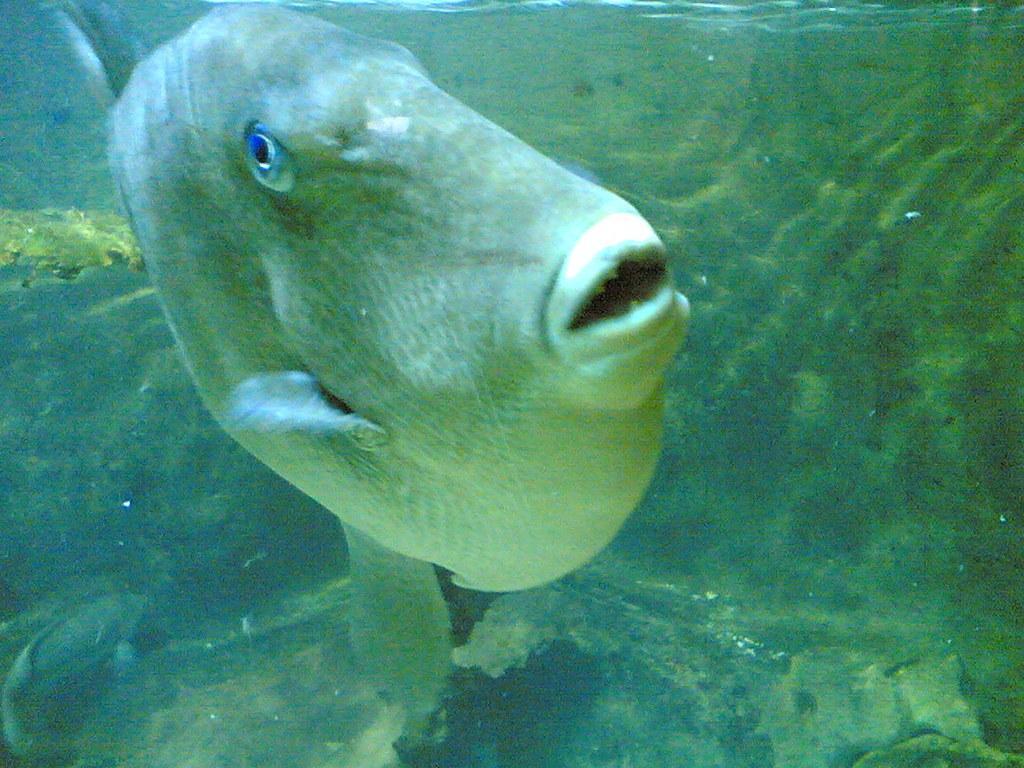In one or two sentences, can you explain what this image depicts? This picture shows a fish in the water. 